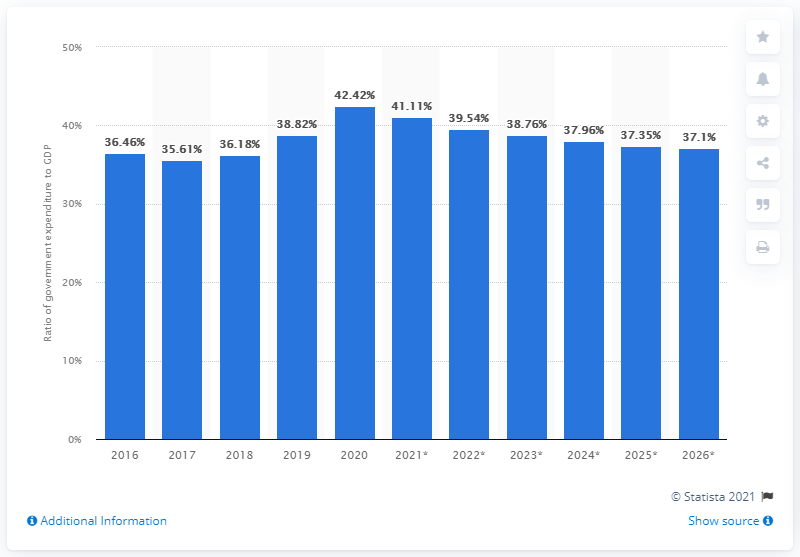Identify some key points in this picture. In 2020, New Zealand spent approximately 42.42% of its gross domestic product. 